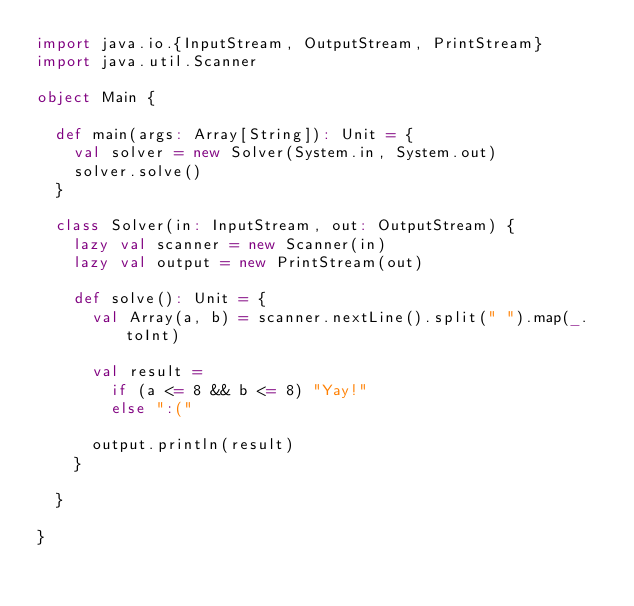<code> <loc_0><loc_0><loc_500><loc_500><_Scala_>import java.io.{InputStream, OutputStream, PrintStream}
import java.util.Scanner

object Main {

  def main(args: Array[String]): Unit = {
    val solver = new Solver(System.in, System.out)
    solver.solve()
  }

  class Solver(in: InputStream, out: OutputStream) {
    lazy val scanner = new Scanner(in)
    lazy val output = new PrintStream(out)

    def solve(): Unit = {
      val Array(a, b) = scanner.nextLine().split(" ").map(_.toInt)

      val result =
        if (a <= 8 && b <= 8) "Yay!"
        else ":("

      output.println(result)
    }

  }

}
</code> 